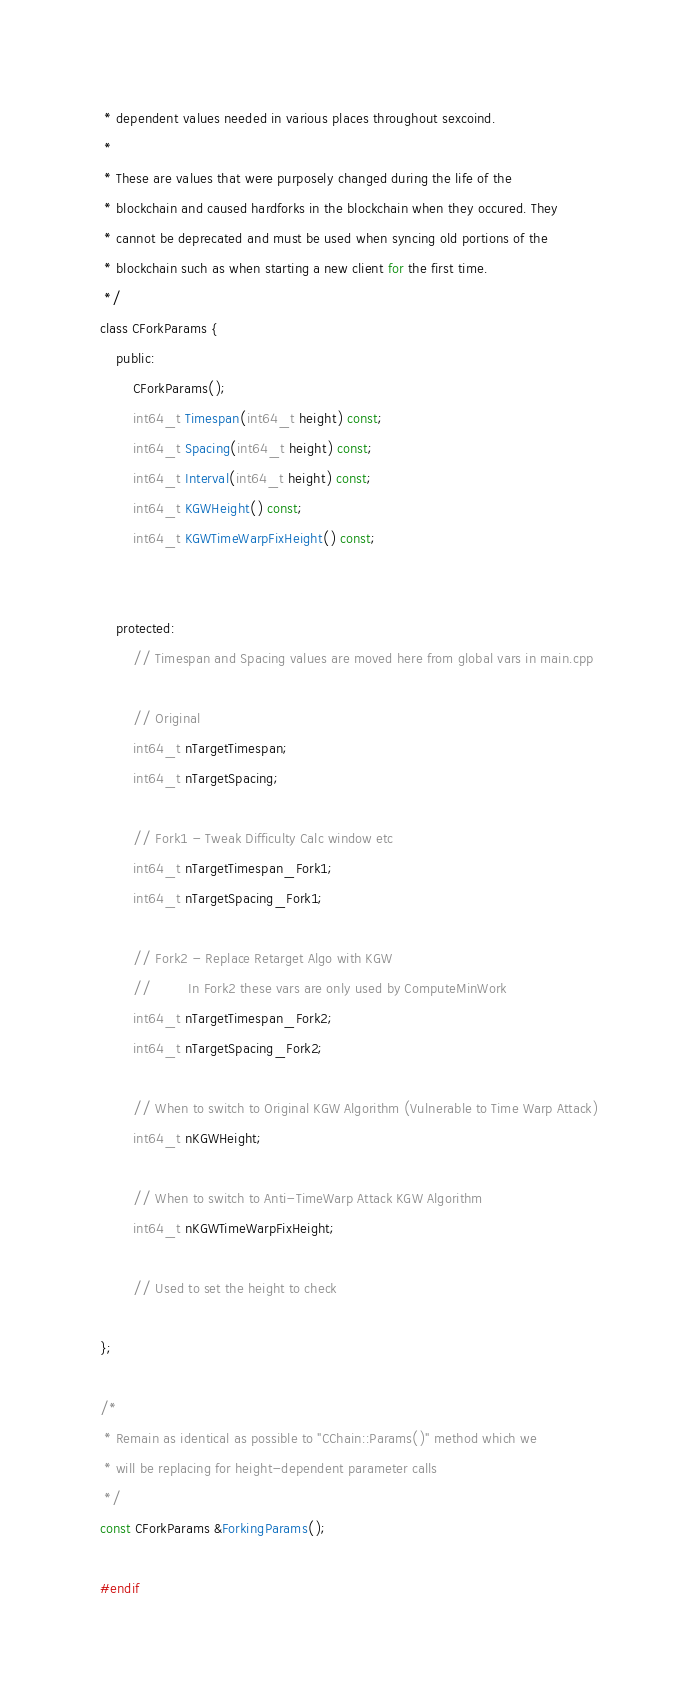Convert code to text. <code><loc_0><loc_0><loc_500><loc_500><_C_> * dependent values needed in various places throughout sexcoind.
 *
 * These are values that were purposely changed during the life of the
 * blockchain and caused hardforks in the blockchain when they occured. They
 * cannot be deprecated and must be used when syncing old portions of the
 * blockchain such as when starting a new client for the first time.
 */
class CForkParams {
    public:
        CForkParams();
        int64_t Timespan(int64_t height) const;
        int64_t Spacing(int64_t height) const;
        int64_t Interval(int64_t height) const;
        int64_t KGWHeight() const;
        int64_t KGWTimeWarpFixHeight() const;

        
    protected:
        // Timespan and Spacing values are moved here from global vars in main.cpp

        // Original
        int64_t nTargetTimespan;
        int64_t nTargetSpacing;

        // Fork1 - Tweak Difficulty Calc window etc
        int64_t nTargetTimespan_Fork1;
        int64_t nTargetSpacing_Fork1;

        // Fork2 - Replace Retarget Algo with KGW
        //         In Fork2 these vars are only used by ComputeMinWork
        int64_t nTargetTimespan_Fork2;
        int64_t nTargetSpacing_Fork2;

        // When to switch to Original KGW Algorithm (Vulnerable to Time Warp Attack)
        int64_t nKGWHeight;

        // When to switch to Anti-TimeWarp Attack KGW Algorithm
        int64_t nKGWTimeWarpFixHeight;
        
        // Used to set the height to check

};

/*
 * Remain as identical as possible to "CChain::Params()" method which we
 * will be replacing for height-dependent parameter calls
 */
const CForkParams &ForkingParams();

#endif</code> 